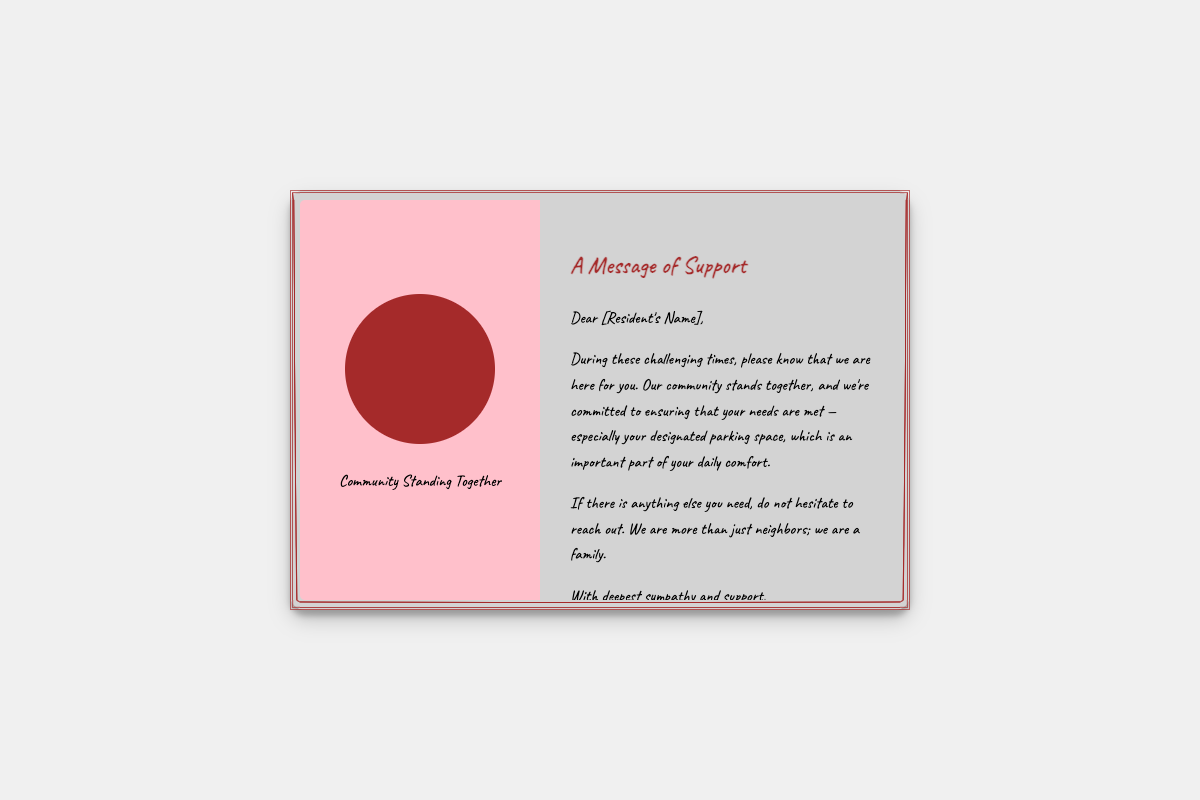what is the background color of the card? The background color of the card is specified as light gray (#D3D3D3).
Answer: light gray who is the card addressed to? The card is addressed to a resident, whose name is indicated as [Resident's Name].
Answer: [Resident's Name] what is the title of the message in the card? The title of the message, as stated in the document, is "A Message of Support."
Answer: A Message of Support what does the illustration represent? The illustration represents the community standing together, as indicated by the text below the illustration.
Answer: Community Standing Together what is highlighted as important for the resident? The document highlights the designated parking space as important for the resident's comfort during challenging times.
Answer: designated parking space who is the author of the card? The author of the card is indicated as [Your Name], signifying the property manager.
Answer: [Your Name] what is the purpose of the card? The purpose of the card is to express sympathy and support during difficult times for the resident.
Answer: express sympathy and support how many sections are there in the card? The card has two main sections: the illustration and the message.
Answer: two 